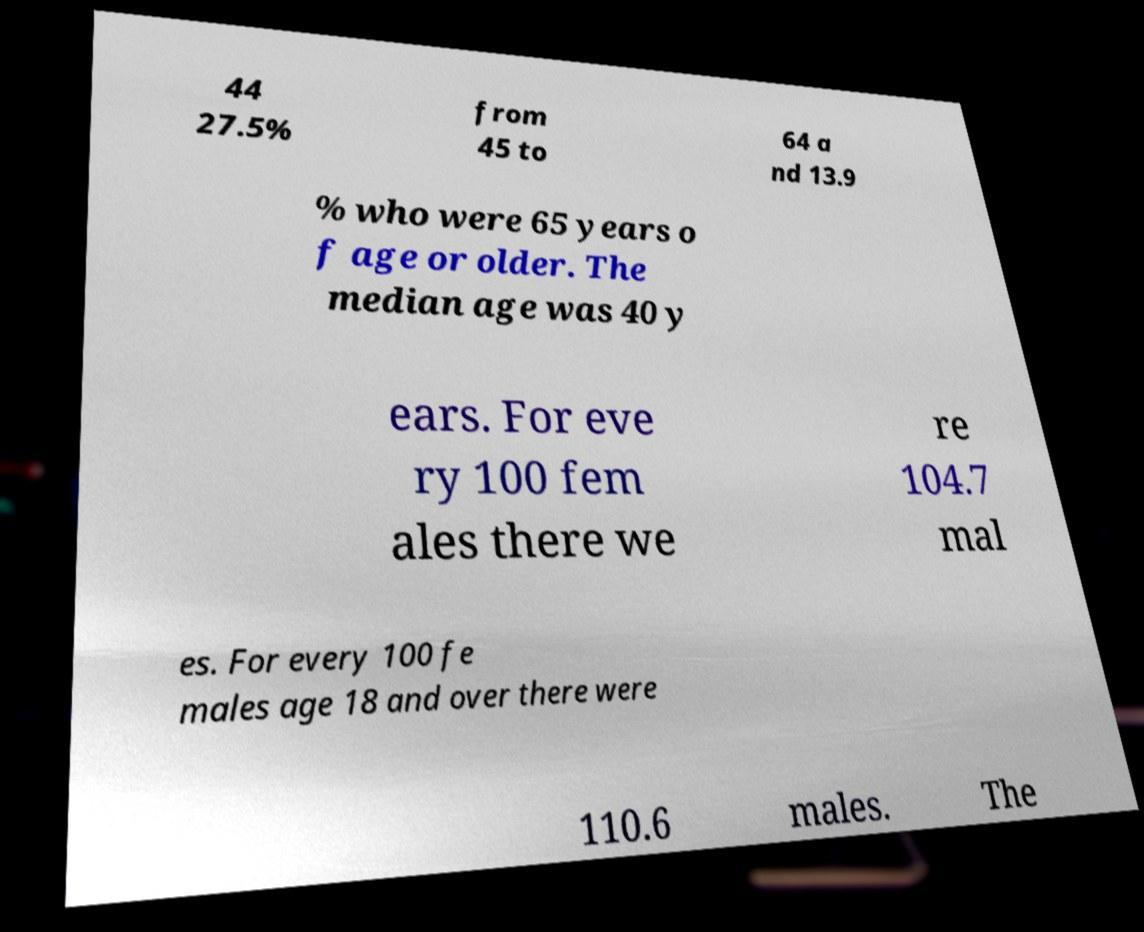Can you read and provide the text displayed in the image?This photo seems to have some interesting text. Can you extract and type it out for me? 44 27.5% from 45 to 64 a nd 13.9 % who were 65 years o f age or older. The median age was 40 y ears. For eve ry 100 fem ales there we re 104.7 mal es. For every 100 fe males age 18 and over there were 110.6 males. The 